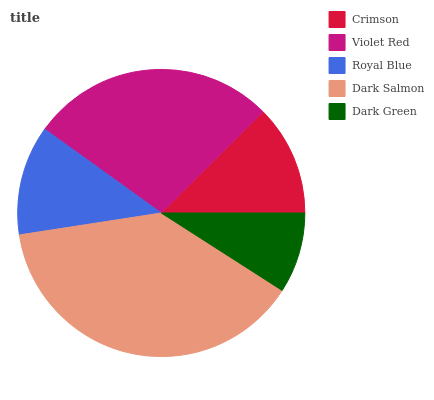Is Dark Green the minimum?
Answer yes or no. Yes. Is Dark Salmon the maximum?
Answer yes or no. Yes. Is Violet Red the minimum?
Answer yes or no. No. Is Violet Red the maximum?
Answer yes or no. No. Is Violet Red greater than Crimson?
Answer yes or no. Yes. Is Crimson less than Violet Red?
Answer yes or no. Yes. Is Crimson greater than Violet Red?
Answer yes or no. No. Is Violet Red less than Crimson?
Answer yes or no. No. Is Crimson the high median?
Answer yes or no. Yes. Is Crimson the low median?
Answer yes or no. Yes. Is Dark Salmon the high median?
Answer yes or no. No. Is Dark Salmon the low median?
Answer yes or no. No. 